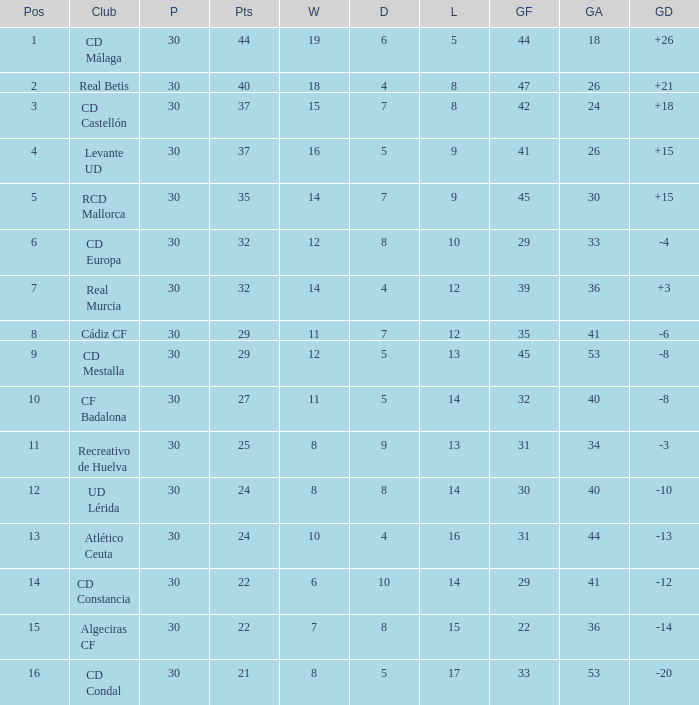What is the number of losses when the goal difference was -8, and position is smaller than 10? 1.0. 